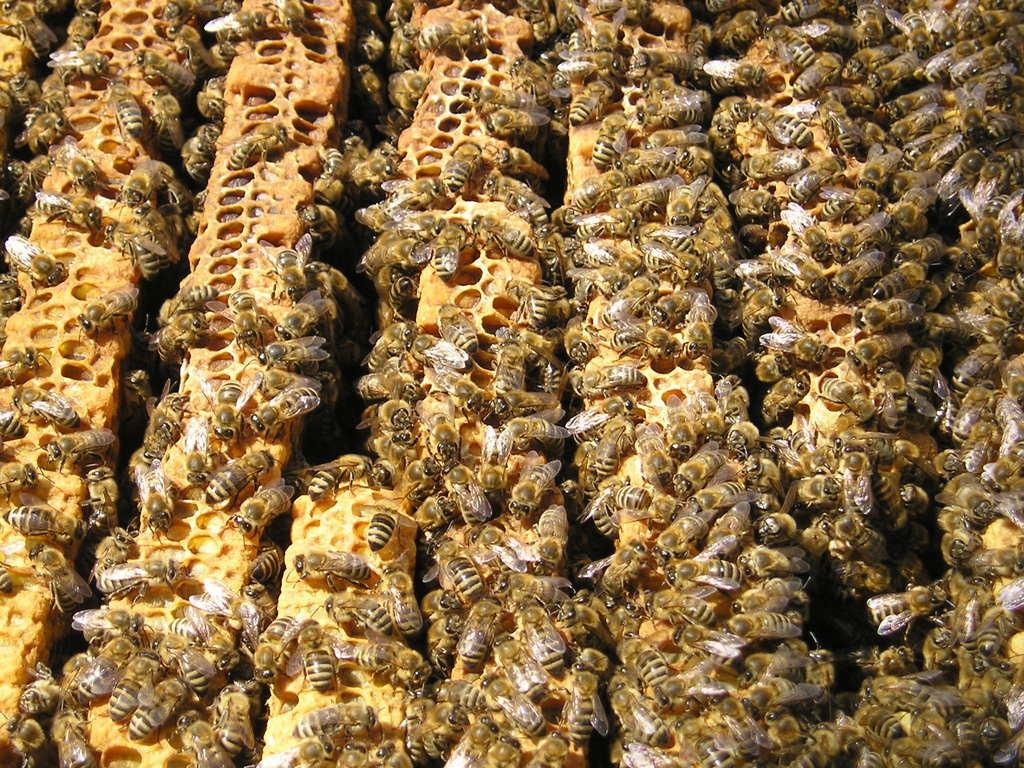What type of insects are present in the image? There are honey bees in the image. What are the honey bees doing or interacting with in the image? The honey bees are on honeycombs. What type of toys can be seen in the image? There are no toys present in the image; it features honey bees on honeycombs. What shape is the balloon in the image? There is no balloon present in the image. 